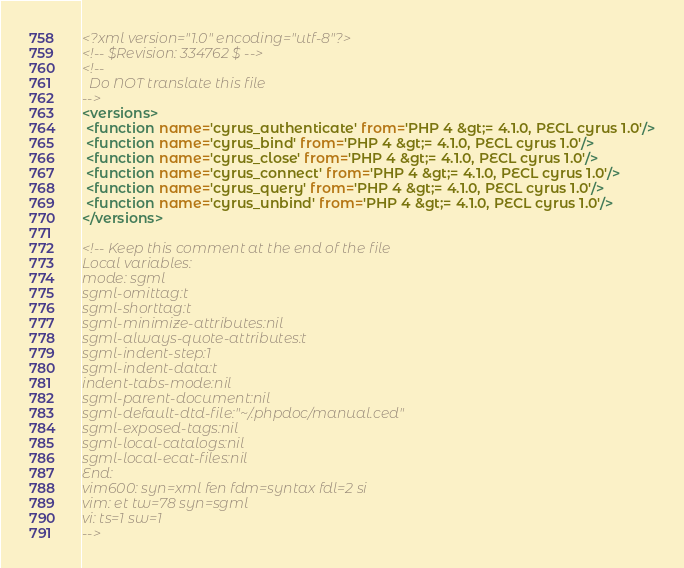<code> <loc_0><loc_0><loc_500><loc_500><_XML_><?xml version="1.0" encoding="utf-8"?>
<!-- $Revision: 334762 $ -->
<!--
  Do NOT translate this file
-->
<versions> 
 <function name='cyrus_authenticate' from='PHP 4 &gt;= 4.1.0, PECL cyrus 1.0'/>
 <function name='cyrus_bind' from='PHP 4 &gt;= 4.1.0, PECL cyrus 1.0'/>
 <function name='cyrus_close' from='PHP 4 &gt;= 4.1.0, PECL cyrus 1.0'/>
 <function name='cyrus_connect' from='PHP 4 &gt;= 4.1.0, PECL cyrus 1.0'/>
 <function name='cyrus_query' from='PHP 4 &gt;= 4.1.0, PECL cyrus 1.0'/>
 <function name='cyrus_unbind' from='PHP 4 &gt;= 4.1.0, PECL cyrus 1.0'/>
</versions>

<!-- Keep this comment at the end of the file
Local variables:
mode: sgml
sgml-omittag:t
sgml-shorttag:t
sgml-minimize-attributes:nil
sgml-always-quote-attributes:t
sgml-indent-step:1
sgml-indent-data:t
indent-tabs-mode:nil
sgml-parent-document:nil
sgml-default-dtd-file:"~/.phpdoc/manual.ced"
sgml-exposed-tags:nil
sgml-local-catalogs:nil
sgml-local-ecat-files:nil
End:
vim600: syn=xml fen fdm=syntax fdl=2 si
vim: et tw=78 syn=sgml
vi: ts=1 sw=1
--></code> 